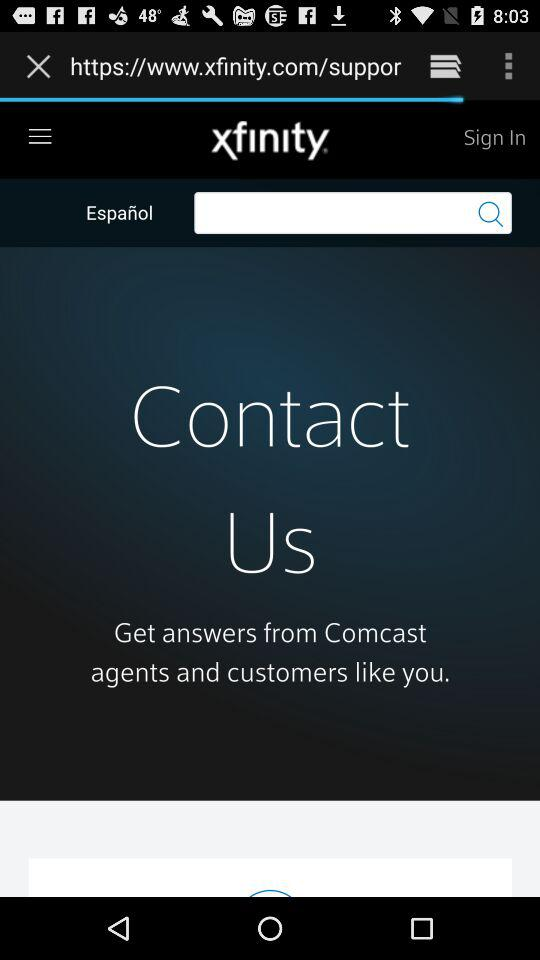What is the name of the application? The name of the application is "xfinity". 